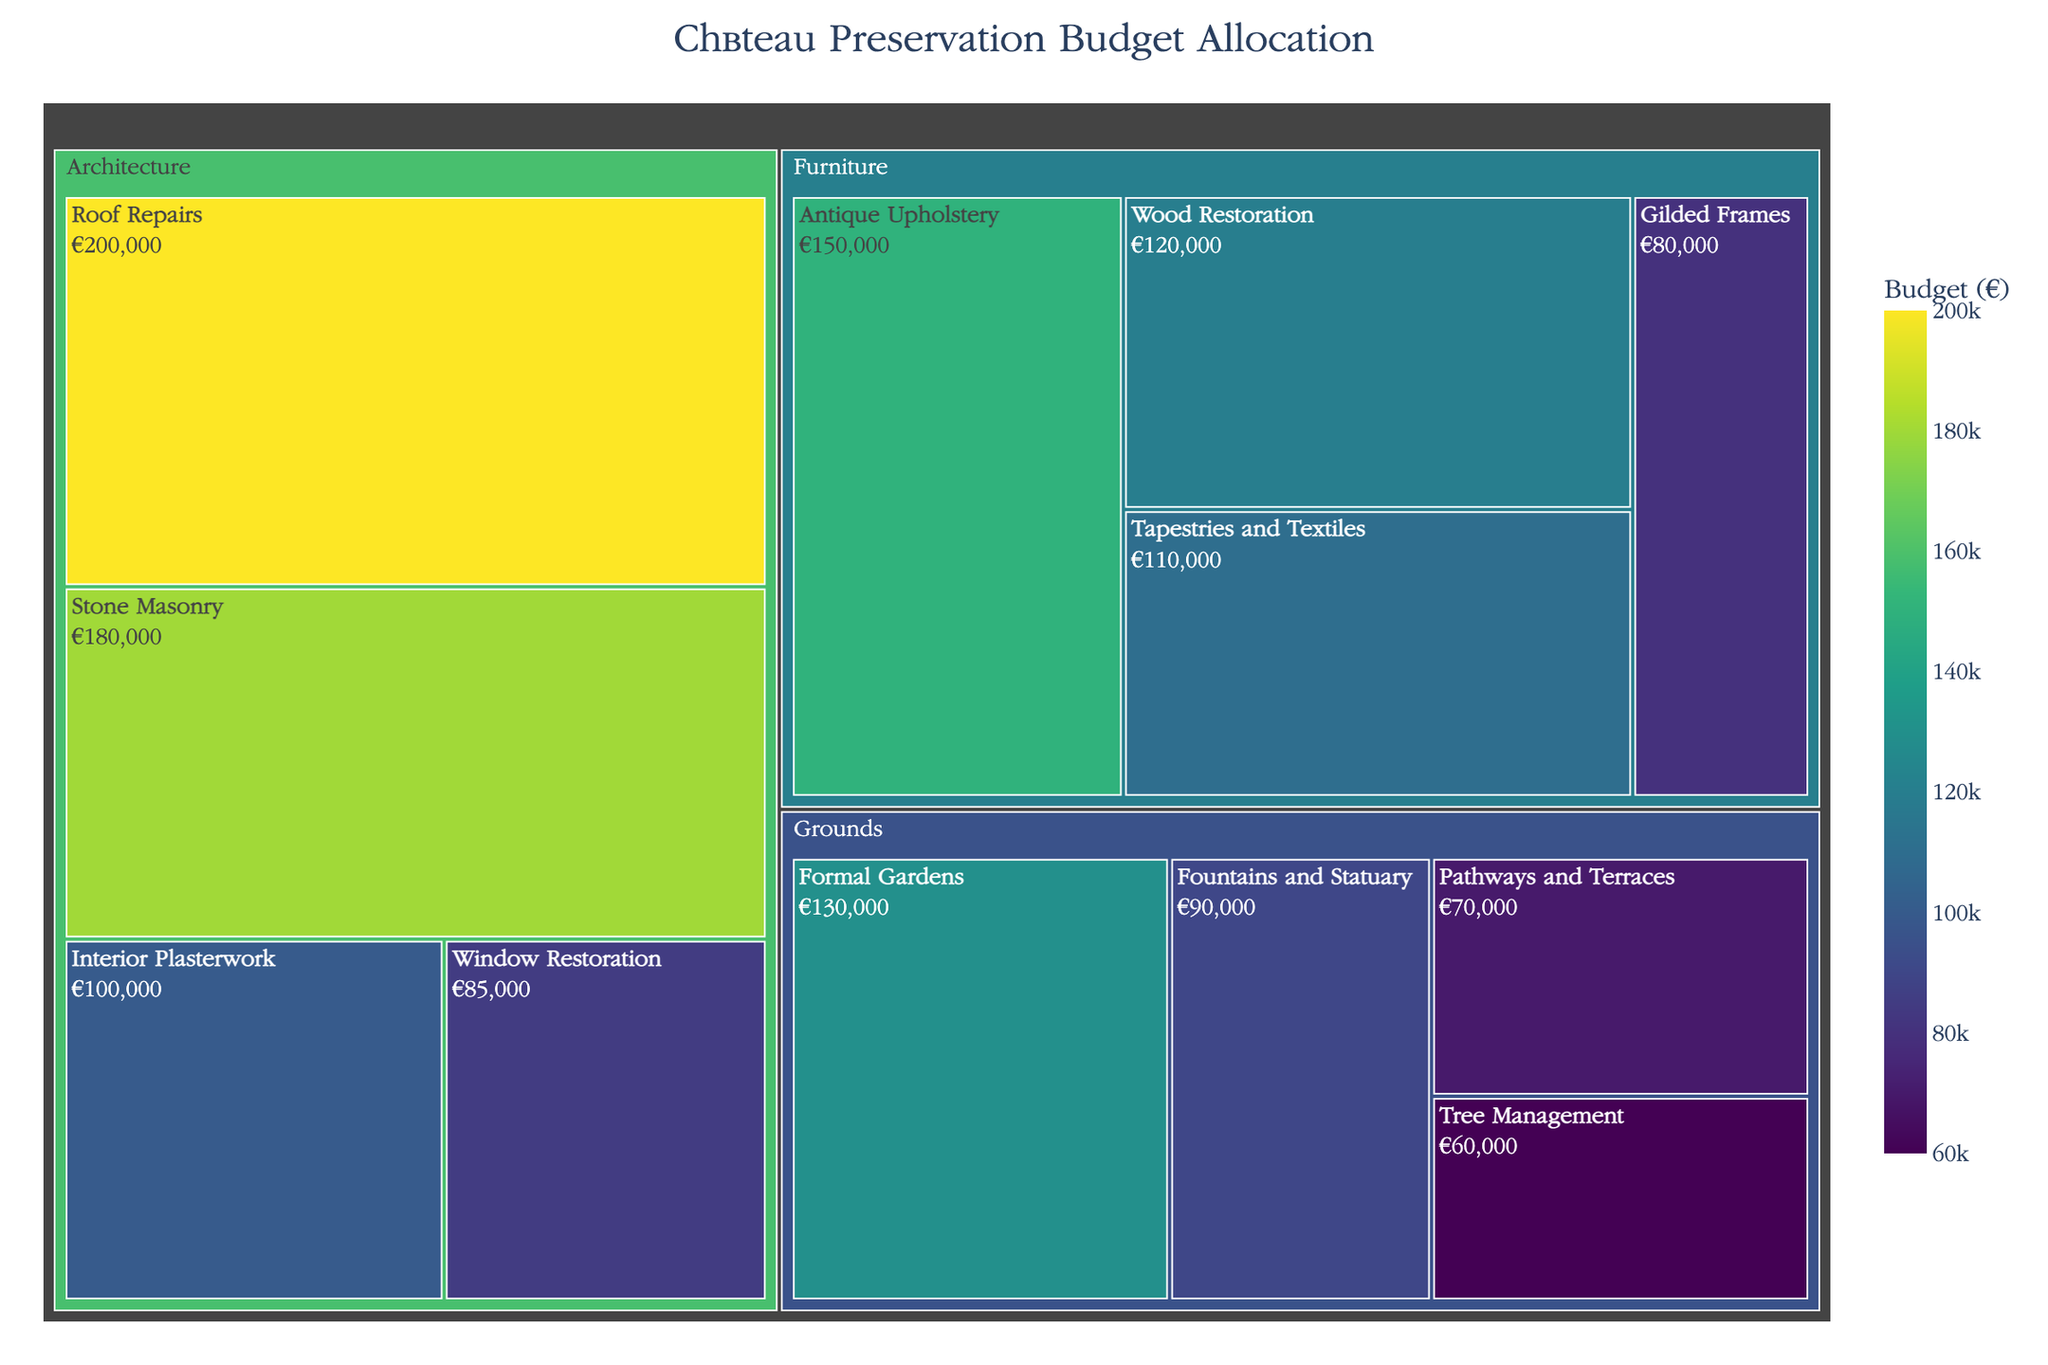How much budget is allocated to the 'Tree Management' subcategory? To find the budget for 'Tree Management', locate the subcategory within the 'Grounds' category on the treemap and read the associated budget value.
Answer: €60,000 Which subcategory under architecture has the highest budget? Check all subcategories within the 'Architecture' category on the treemap and compare their budget values. The one with the highest amount is the answer.
Answer: Roof Repairs How does the budget for 'Antique Upholstery' compare to 'Wood Restoration'? Locate both 'Antique Upholstery' and 'Wood Restoration' within the 'Furniture' category and compare their budget values directly.
Answer: Antique Upholstery has a higher budget What's the total budget allocated to the 'Furniture' category? Sum the budgets of all subcategories within the 'Furniture' category. Adding: €150,000 (Antique Upholstery) + €120,000 (Wood Restoration) + €80,000 (Gilded Frames) + €110,000 (Tapestries and Textiles) = €460,000.
Answer: €460,000 Which subcategory under 'Grounds' has the lowest budget? Compare the budget values of all subcategories within the 'Grounds' category and identify the one with the smallest amount.
Answer: Tree Management Between 'Interior Plasterwork' and 'Window Restoration', which has a higher budget and by how much? Locate both subcategories within the 'Architecture' category and subtract the budget value of 'Window Restoration' from 'Interior Plasterwork': €100,000 (Interior Plasterwork) - €85,000 (Window Restoration) = €15,000.
Answer: Interior Plasterwork by €15,000 What is the average budget allocated to subcategories within the 'Grounds' category? Sum the budgets of all subcategories in 'Grounds' and divide by the number of subcategories: (€130,000 + €90,000 + €70,000 + €60,000)/4 = €87,500.
Answer: €87,500 How much more budget is allocated to 'Roof Repairs' compared to 'Pathways and Terraces'? Subtract the budget of 'Pathways and Terraces' from 'Roof Repairs': €200,000 (Roof Repairs) - €70,000 (Pathways and Terraces) = €130,000.
Answer: €130,000 Which category has the highest total budget allocation? Sum the budget values of all subcategories for each category and compare. The largest total indicates the highest allocation. Compare: Furniture: €460,000, Architecture: €565,000, Grounds: €350,000.
Answer: Architecture What is the color scale representing in this treemap? The color scale represents the budget values, with different shades indicating the amount of budget allocated to each subcategory. The title and legend typically indicate this relationship.
Answer: Budget (€) 